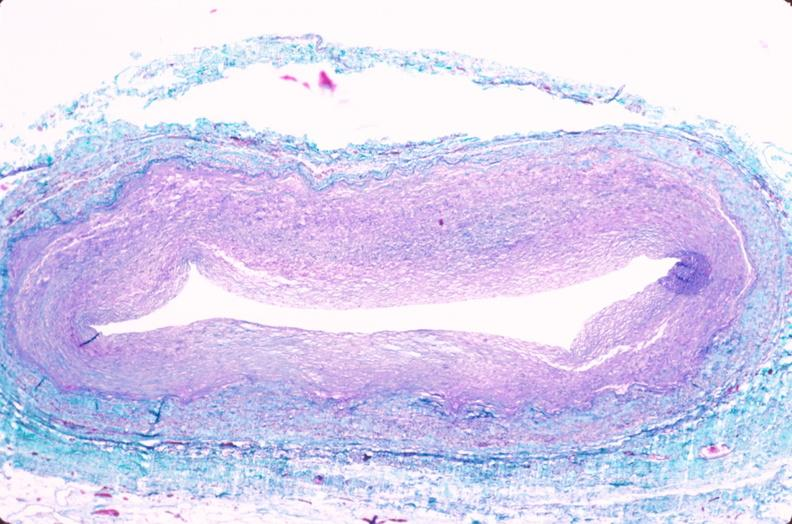s vasculature present?
Answer the question using a single word or phrase. Yes 